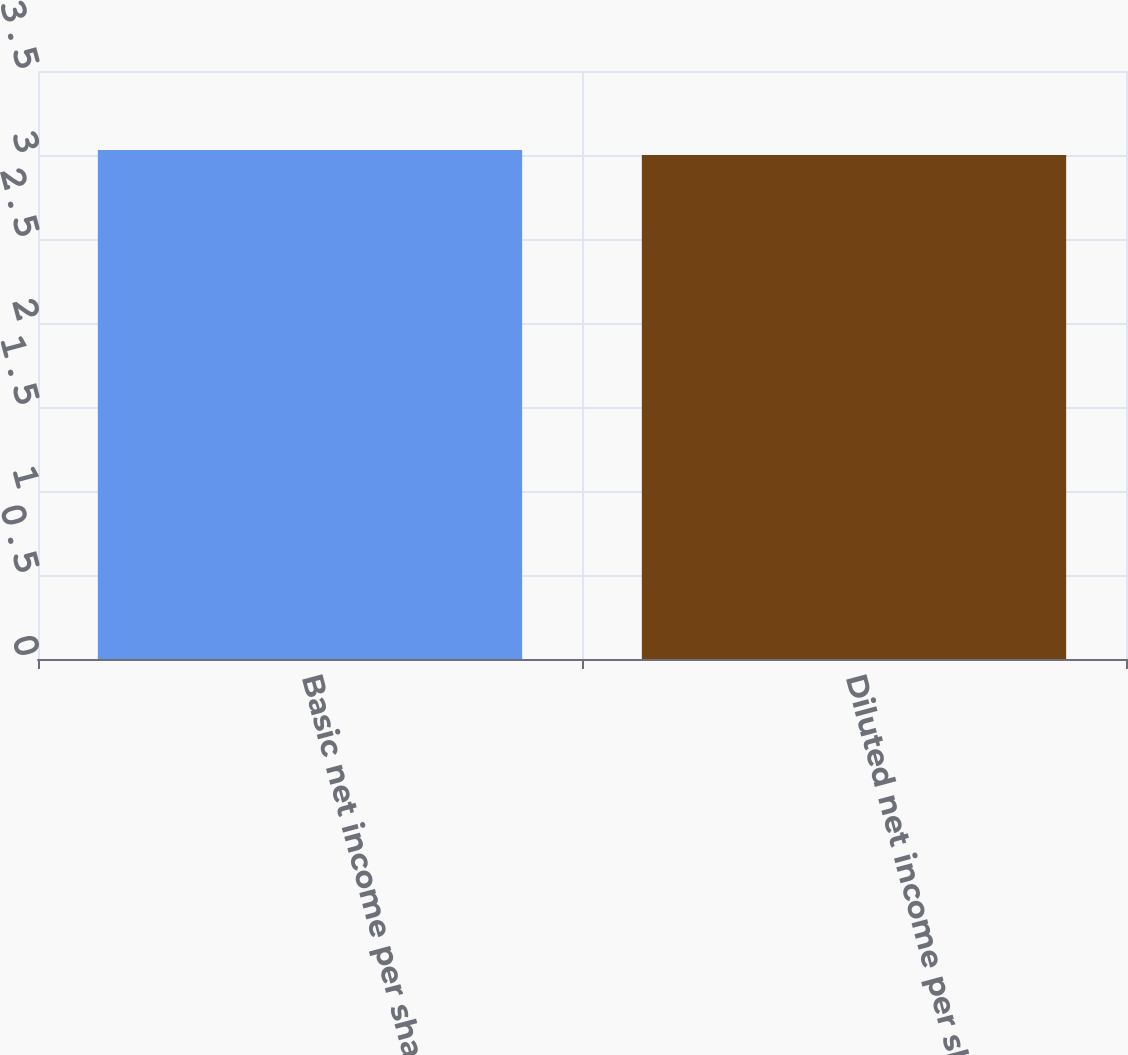Convert chart. <chart><loc_0><loc_0><loc_500><loc_500><bar_chart><fcel>Basic net income per share<fcel>Diluted net income per share<nl><fcel>3.03<fcel>3<nl></chart> 